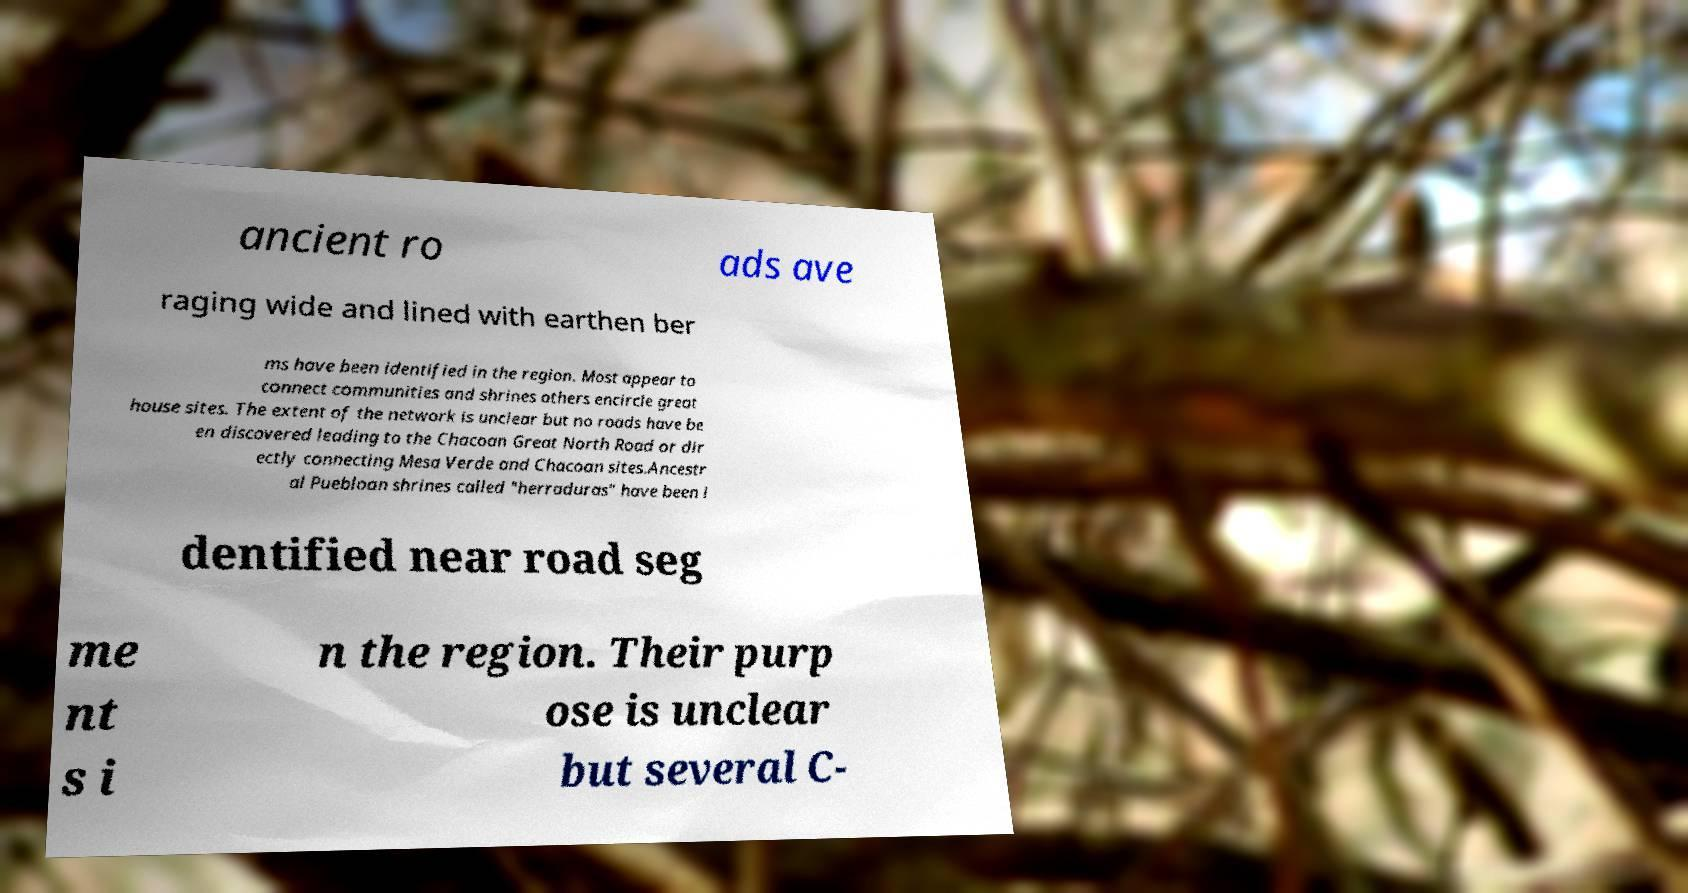What messages or text are displayed in this image? I need them in a readable, typed format. ancient ro ads ave raging wide and lined with earthen ber ms have been identified in the region. Most appear to connect communities and shrines others encircle great house sites. The extent of the network is unclear but no roads have be en discovered leading to the Chacoan Great North Road or dir ectly connecting Mesa Verde and Chacoan sites.Ancestr al Puebloan shrines called "herraduras" have been i dentified near road seg me nt s i n the region. Their purp ose is unclear but several C- 